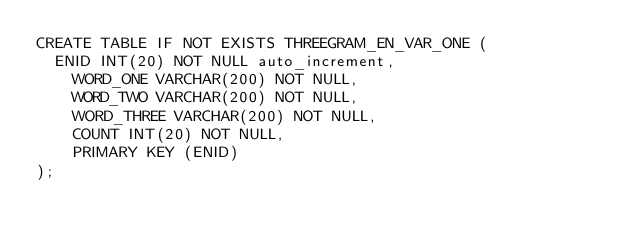<code> <loc_0><loc_0><loc_500><loc_500><_SQL_>CREATE TABLE IF NOT EXISTS THREEGRAM_EN_VAR_ONE (
	ENID INT(20) NOT NULL auto_increment,
    WORD_ONE VARCHAR(200) NOT NULL,
    WORD_TWO VARCHAR(200) NOT NULL,
    WORD_THREE VARCHAR(200) NOT NULL,
    COUNT INT(20) NOT NULL,
    PRIMARY KEY (ENID)
);
</code> 